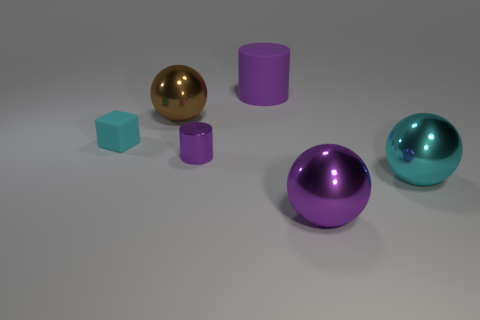Subtract all big cyan spheres. How many spheres are left? 2 Subtract all cylinders. How many objects are left? 4 Add 3 green rubber balls. How many objects exist? 9 Subtract all cyan balls. How many balls are left? 2 Subtract 1 cylinders. How many cylinders are left? 1 Add 4 blocks. How many blocks are left? 5 Add 2 purple balls. How many purple balls exist? 3 Subtract 1 purple spheres. How many objects are left? 5 Subtract all blue spheres. Subtract all brown cylinders. How many spheres are left? 3 Subtract all green metallic cubes. Subtract all large metal spheres. How many objects are left? 3 